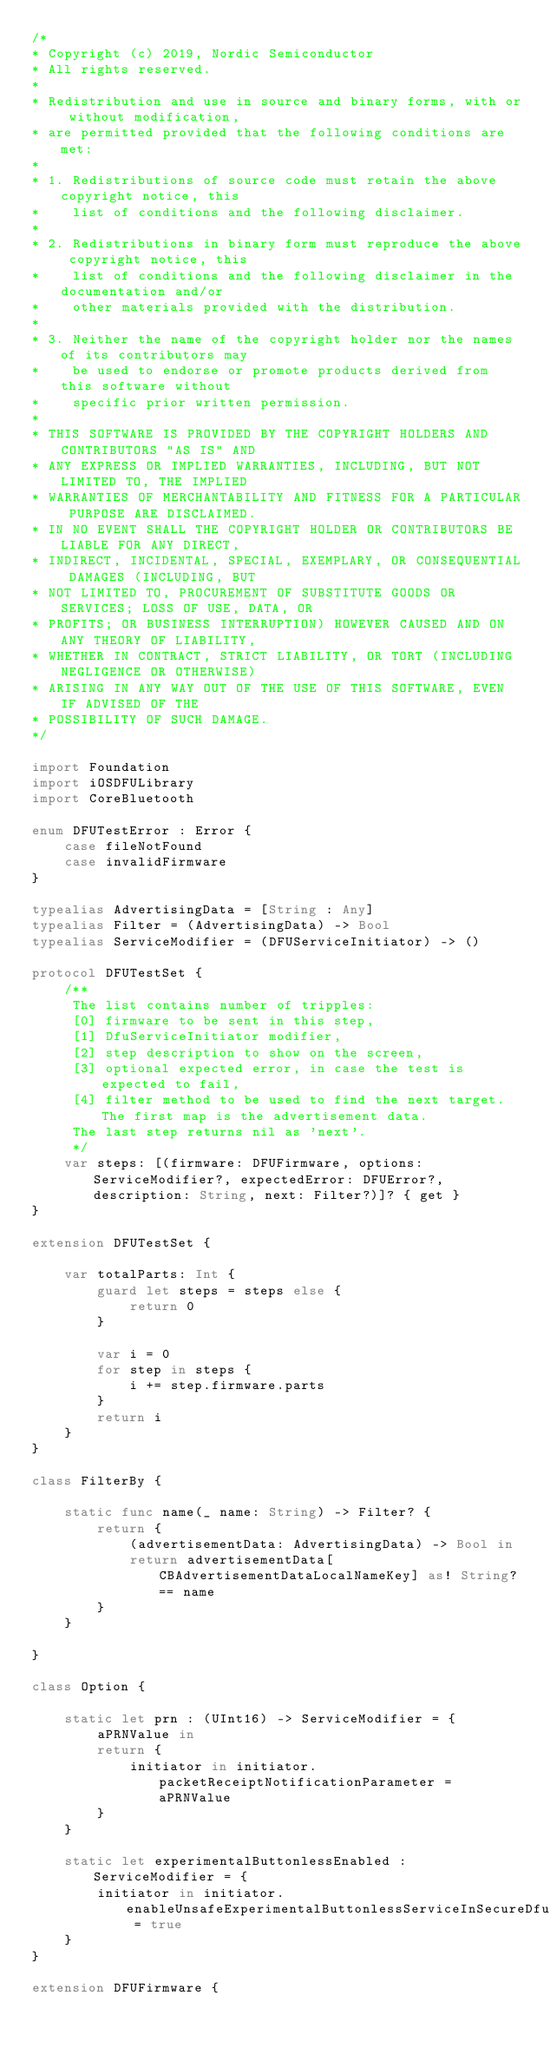Convert code to text. <code><loc_0><loc_0><loc_500><loc_500><_Swift_>/*
* Copyright (c) 2019, Nordic Semiconductor
* All rights reserved.
*
* Redistribution and use in source and binary forms, with or without modification,
* are permitted provided that the following conditions are met:
*
* 1. Redistributions of source code must retain the above copyright notice, this
*    list of conditions and the following disclaimer.
*
* 2. Redistributions in binary form must reproduce the above copyright notice, this
*    list of conditions and the following disclaimer in the documentation and/or
*    other materials provided with the distribution.
*
* 3. Neither the name of the copyright holder nor the names of its contributors may
*    be used to endorse or promote products derived from this software without
*    specific prior written permission.
*
* THIS SOFTWARE IS PROVIDED BY THE COPYRIGHT HOLDERS AND CONTRIBUTORS "AS IS" AND
* ANY EXPRESS OR IMPLIED WARRANTIES, INCLUDING, BUT NOT LIMITED TO, THE IMPLIED
* WARRANTIES OF MERCHANTABILITY AND FITNESS FOR A PARTICULAR PURPOSE ARE DISCLAIMED.
* IN NO EVENT SHALL THE COPYRIGHT HOLDER OR CONTRIBUTORS BE LIABLE FOR ANY DIRECT,
* INDIRECT, INCIDENTAL, SPECIAL, EXEMPLARY, OR CONSEQUENTIAL DAMAGES (INCLUDING, BUT
* NOT LIMITED TO, PROCUREMENT OF SUBSTITUTE GOODS OR SERVICES; LOSS OF USE, DATA, OR
* PROFITS; OR BUSINESS INTERRUPTION) HOWEVER CAUSED AND ON ANY THEORY OF LIABILITY,
* WHETHER IN CONTRACT, STRICT LIABILITY, OR TORT (INCLUDING NEGLIGENCE OR OTHERWISE)
* ARISING IN ANY WAY OUT OF THE USE OF THIS SOFTWARE, EVEN IF ADVISED OF THE
* POSSIBILITY OF SUCH DAMAGE.
*/

import Foundation
import iOSDFULibrary
import CoreBluetooth

enum DFUTestError : Error {
    case fileNotFound
    case invalidFirmware
}

typealias AdvertisingData = [String : Any]
typealias Filter = (AdvertisingData) -> Bool
typealias ServiceModifier = (DFUServiceInitiator) -> ()

protocol DFUTestSet {
    /**
     The list contains number of tripples:
     [0] firmware to be sent in this step,
     [1] DfuServiceInitiator modifier,
     [2] step description to show on the screen,
     [3] optional expected error, in case the test is expected to fail,
     [4] filter method to be used to find the next target. The first map is the advertisement data.
     The last step returns nil as 'next'.
     */
    var steps: [(firmware: DFUFirmware, options: ServiceModifier?, expectedError: DFUError?, description: String, next: Filter?)]? { get }
}

extension DFUTestSet {
    
    var totalParts: Int {
        guard let steps = steps else {
            return 0
        }
        
        var i = 0
        for step in steps {
            i += step.firmware.parts
        }
        return i
    }
}

class FilterBy {
    
    static func name(_ name: String) -> Filter? {
        return {
            (advertisementData: AdvertisingData) -> Bool in
            return advertisementData[CBAdvertisementDataLocalNameKey] as! String? == name
        }
    }
    
}

class Option {
    
    static let prn : (UInt16) -> ServiceModifier = {
        aPRNValue in
        return {
            initiator in initiator.packetReceiptNotificationParameter = aPRNValue
        }
    }
    
    static let experimentalButtonlessEnabled : ServiceModifier = {
        initiator in initiator.enableUnsafeExperimentalButtonlessServiceInSecureDfu = true
    }
}

extension DFUFirmware {
    </code> 